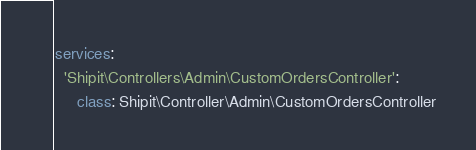<code> <loc_0><loc_0><loc_500><loc_500><_YAML_>services:
  'Shipit\Controllers\Admin\CustomOrdersController':
     class: Shipit\Controller\Admin\CustomOrdersController
</code> 